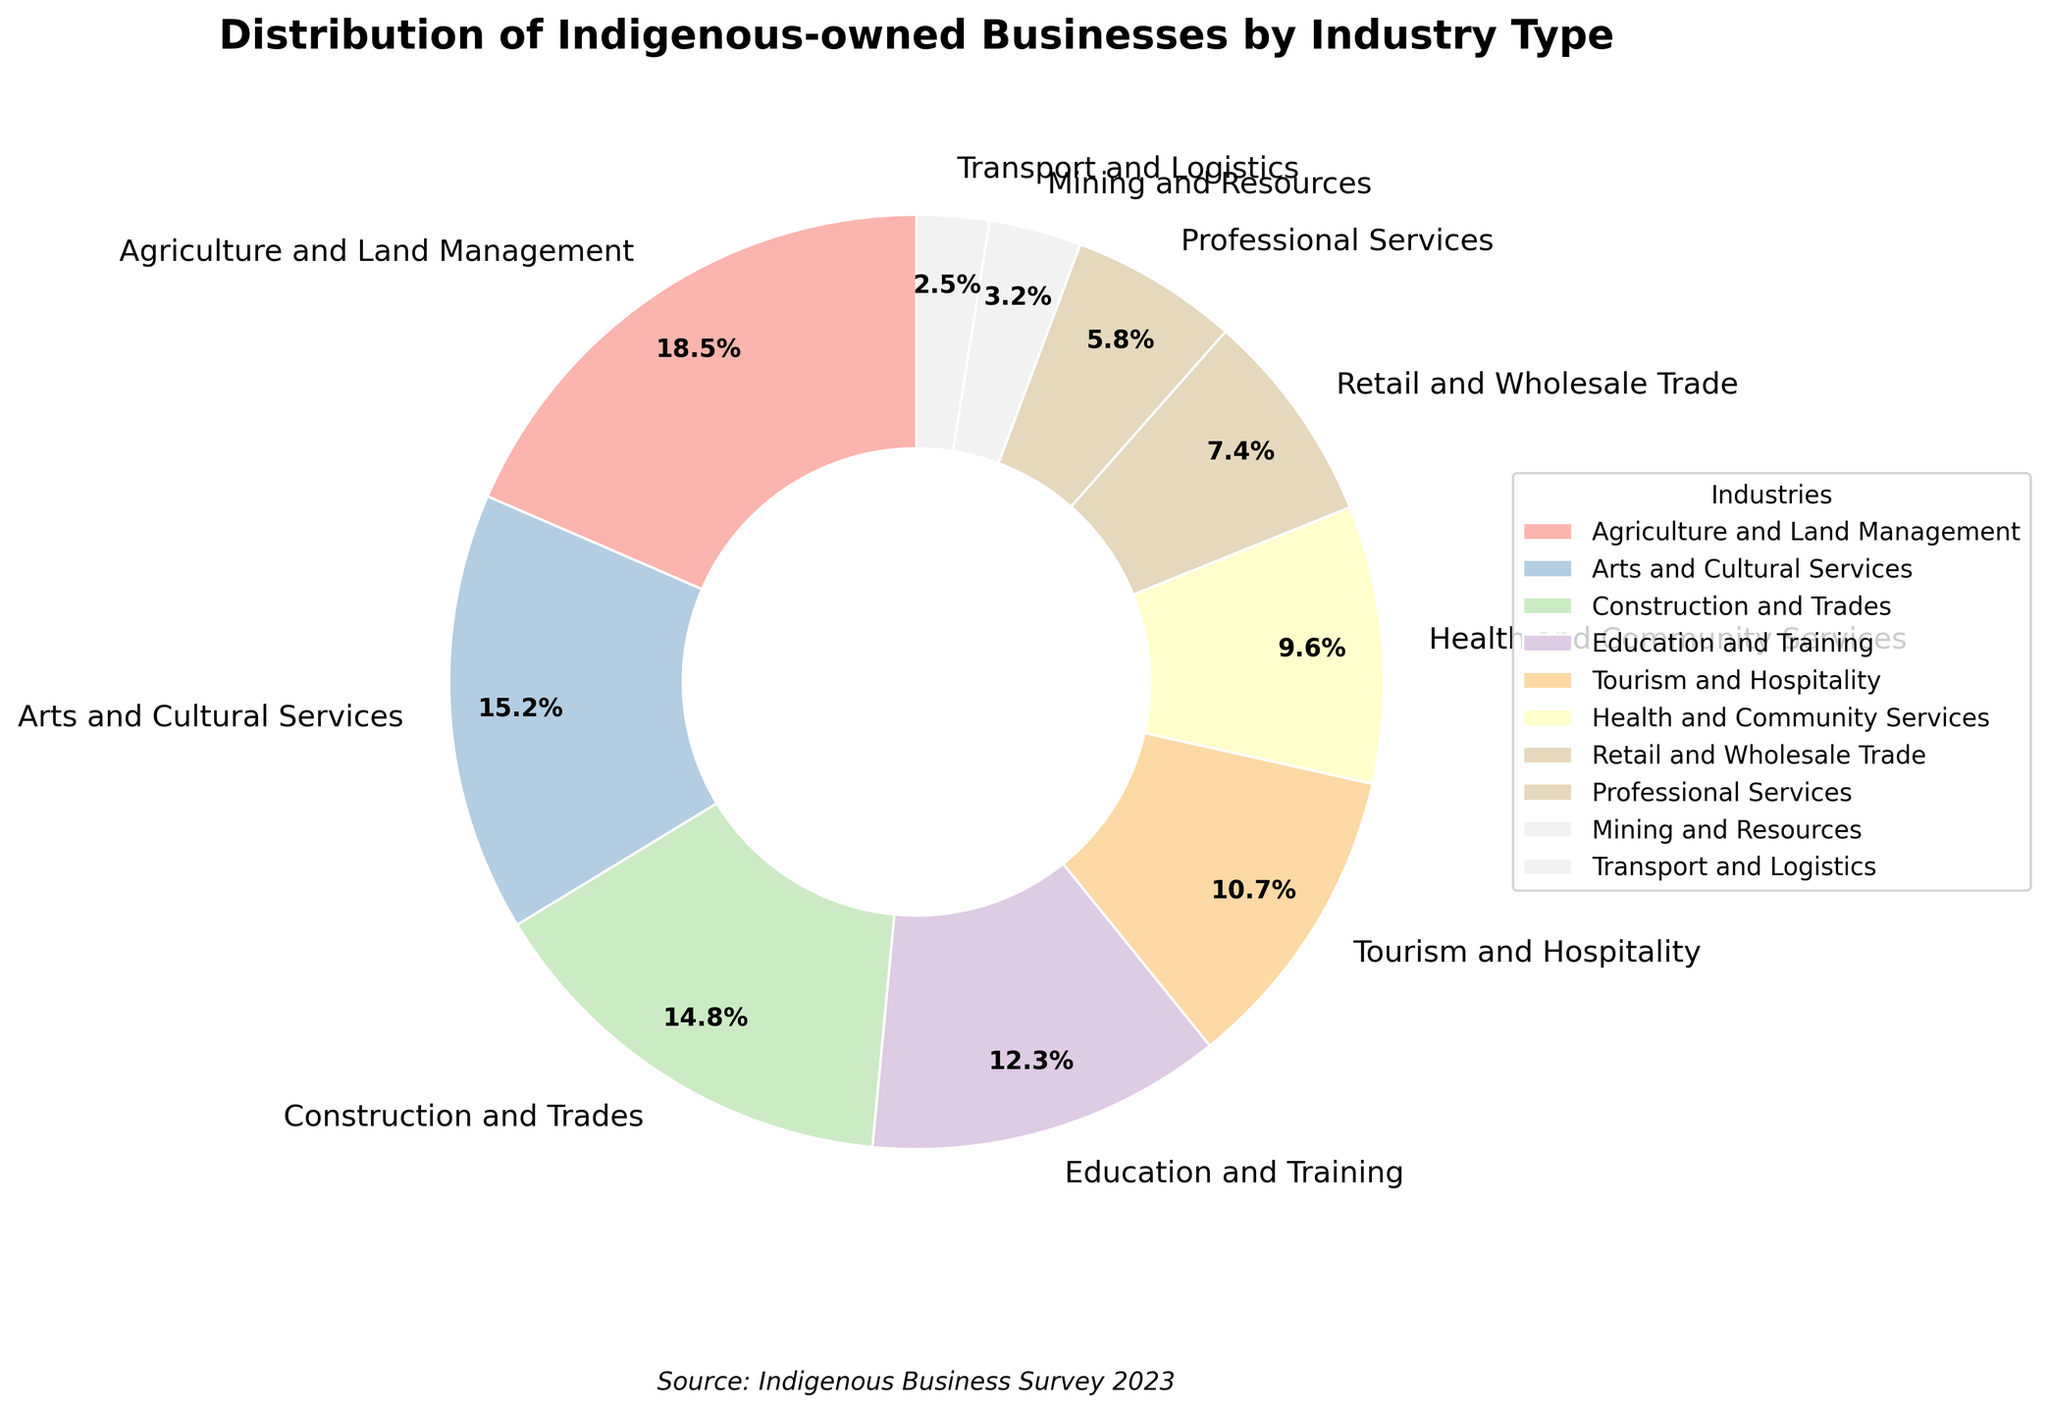What is the industry with the highest percentage of Indigenous-owned businesses? The industry with the highest percentage can be identified by finding the slice of the pie chart that has the largest area. Based on the data, 'Agriculture and Land Management' has the largest slice.
Answer: Agriculture and Land Management What is the combined percentage of businesses in Construction and Trades, and Arts and Cultural Services? To find the combined percentage, we add the percentages of the two industries: Construction and Trades (14.8%) and Arts and Cultural Services (15.2%). So, 14.8% + 15.2% = 30%.
Answer: 30% Which industry has a smaller percentage of Indigenous-owned businesses: Tourism and Hospitality or Health and Community Services? By comparing the slices, we see that 'Health and Community Services' has a percentage of 9.6%, and 'Tourism and Hospitality' has a higher percentage of 10.7%.
Answer: Health and Community Services What is the difference in percentage between Retail and Wholesale Trade, and Mining and Resources? To find the difference, subtract the smaller percentage from the larger: Retail and Wholesale Trade (7.4%) - Mining and Resources (3.2%) = 4.2%.
Answer: 4.2% If we combine the Education and Training percentage with the Health and Community Services percentage, what will the total be? Addition of Education and Training (12.3%) and Health and Community Services (9.6%) yields: 12.3% + 9.6% = 21.9%.
Answer: 21.9% Which industry type occupies the smallest slice of the pie chart? The smallest slice of the pie chart can be identified by comparing all the slices. 'Transport and Logistics' has the smallest percentage of 2.5%.
Answer: Transport and Logistics Among Professional Services and Retail and Wholesale Trade, which industry has a larger percentage of Indigenous-owned businesses? By comparing the pie slices, Professional Services has a percentage of 5.8%, while Retail and Wholesale Trade has a larger percentage of 7.4%.
Answer: Retail and Wholesale Trade What is the percentage difference between the industries with the highest and lowest representations? The highest percentage is 'Agriculture and Land Management' at 18.5%, and the lowest is 'Transport and Logistics' at 2.5%. Subtracting the smallest from the largest gives 18.5% - 2.5% = 16%.
Answer: 16% How much more percentage of Indigenous-owned businesses is there in Education and Training compared to Mining and Resources? Subtract the percentage of Mining and Resources (3.2%) from that of Education and Training (12.3%): 12.3% - 3.2% = 9.1%.
Answer: 9.1% Which industries have a combined total percentage greater than 50% when summed together? Adding the percentages of industries together: Agriculture and Land Management (18.5%), Arts and Cultural Services (15.2%), and Construction and Trades (14.8%) gives a combined total: 18.5% + 15.2% + 14.8% = 48.5%. Including Education and Training (12.3%) reaches above 50%, i.e., 48.5% + 12.3% = 60.8%.
Answer: Agriculture and Land Management, Arts and Cultural Services, Construction and Trades, Education and Training 